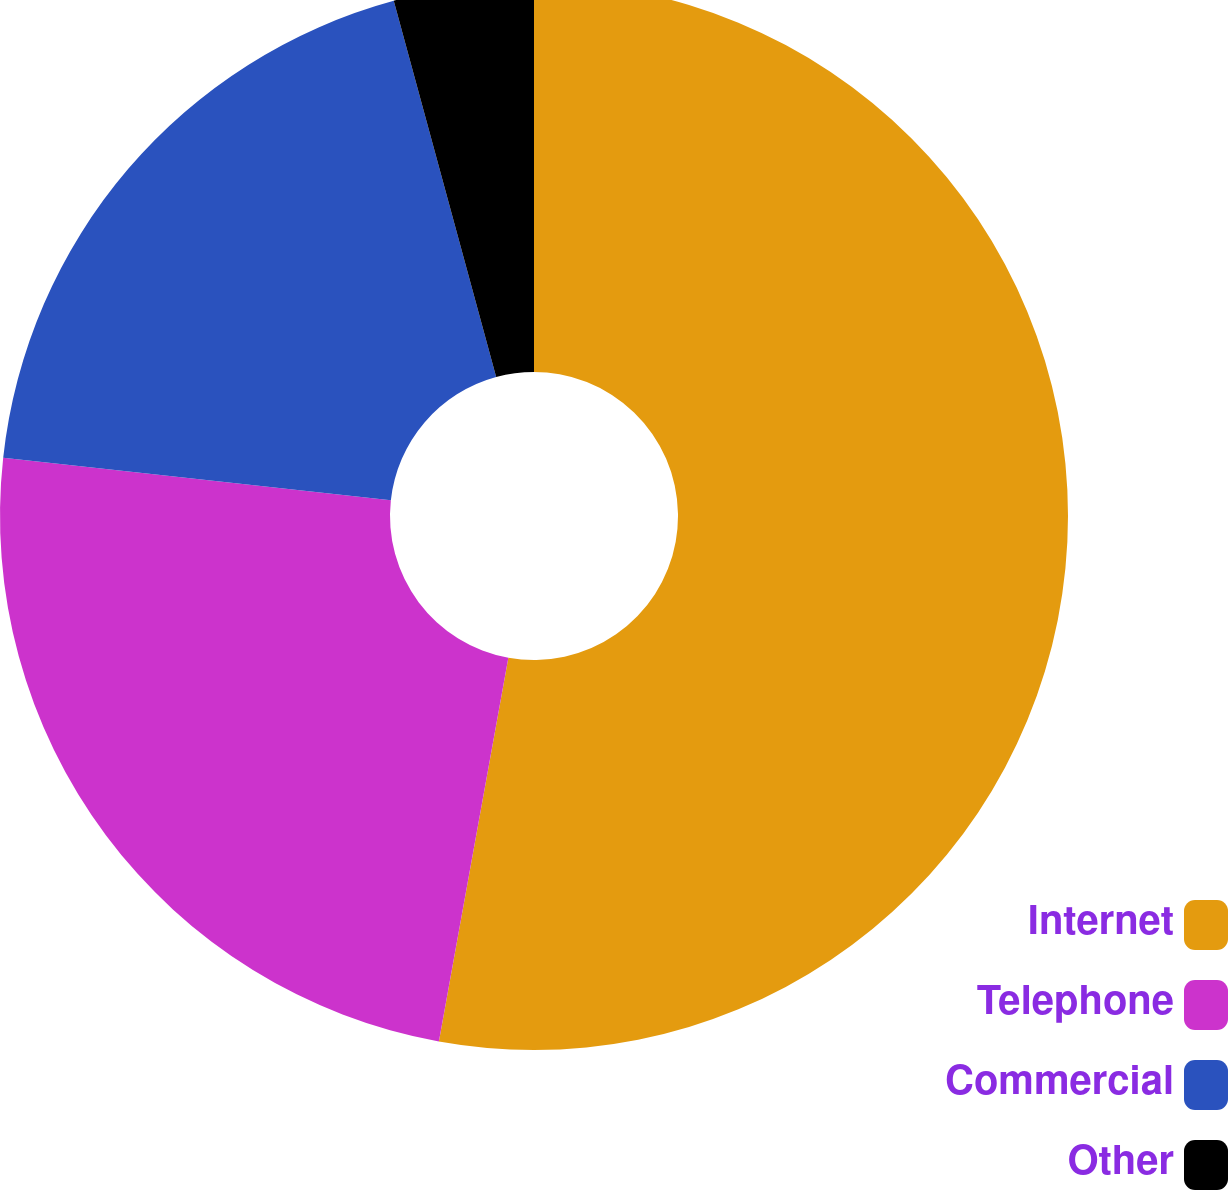Convert chart to OTSL. <chart><loc_0><loc_0><loc_500><loc_500><pie_chart><fcel>Internet<fcel>Telephone<fcel>Commercial<fcel>Other<nl><fcel>52.85%<fcel>23.89%<fcel>19.03%<fcel>4.23%<nl></chart> 